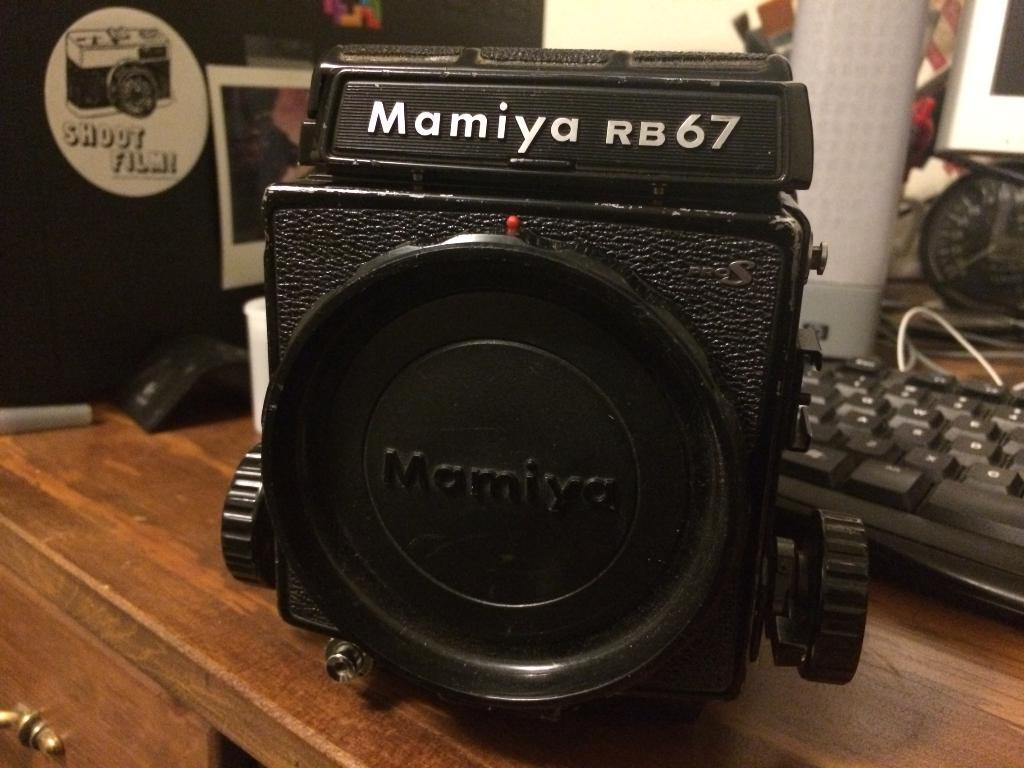<image>
Provide a brief description of the given image. A black camera with the word Mamiya on the top. 